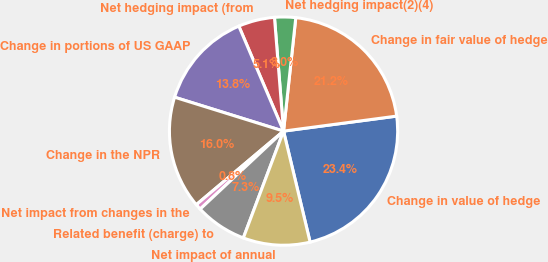<chart> <loc_0><loc_0><loc_500><loc_500><pie_chart><fcel>Change in value of hedge<fcel>Change in fair value of hedge<fcel>Net hedging impact(2)(4)<fcel>Net hedging impact (from<fcel>Change in portions of US GAAP<fcel>Change in the NPR<fcel>Net impact from changes in the<fcel>Related benefit (charge) to<fcel>Net impact of annual<nl><fcel>23.36%<fcel>21.19%<fcel>2.98%<fcel>5.14%<fcel>13.79%<fcel>15.95%<fcel>0.82%<fcel>7.3%<fcel>9.47%<nl></chart> 